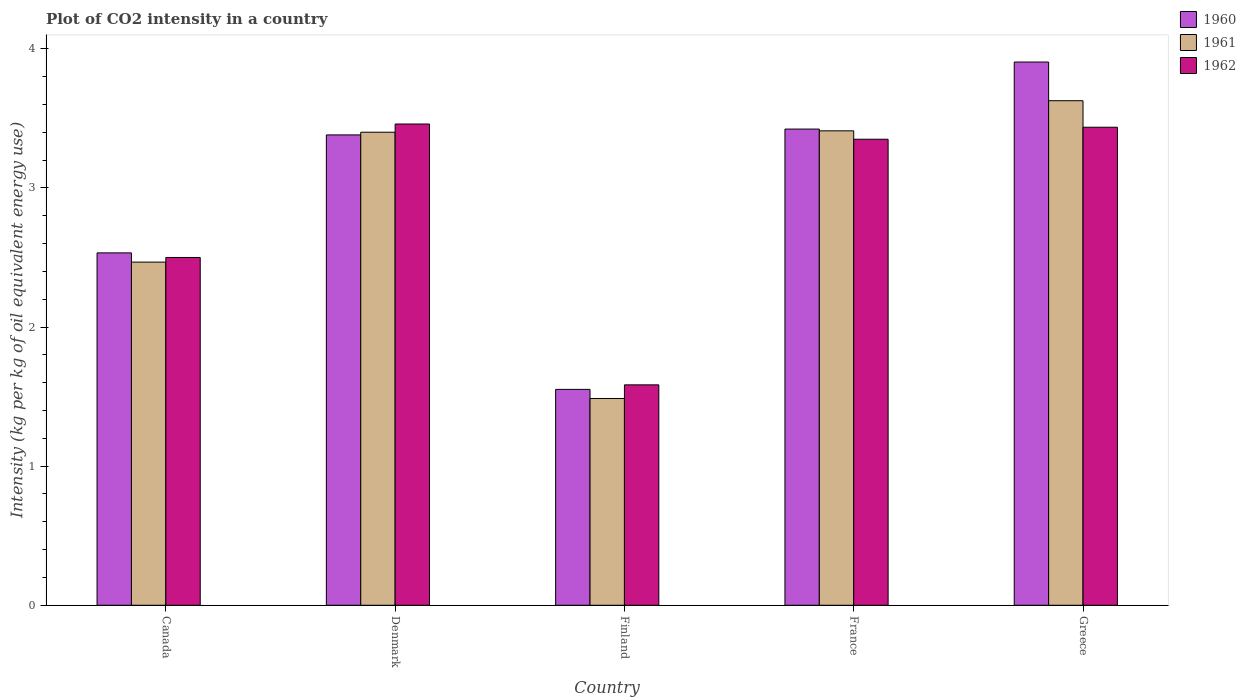Are the number of bars on each tick of the X-axis equal?
Make the answer very short. Yes. How many bars are there on the 5th tick from the left?
Offer a very short reply. 3. How many bars are there on the 5th tick from the right?
Keep it short and to the point. 3. What is the CO2 intensity in in 1961 in Greece?
Give a very brief answer. 3.63. Across all countries, what is the maximum CO2 intensity in in 1962?
Give a very brief answer. 3.46. Across all countries, what is the minimum CO2 intensity in in 1961?
Ensure brevity in your answer.  1.49. In which country was the CO2 intensity in in 1961 maximum?
Your answer should be very brief. Greece. What is the total CO2 intensity in in 1961 in the graph?
Your response must be concise. 14.39. What is the difference between the CO2 intensity in in 1961 in Canada and that in Greece?
Offer a terse response. -1.16. What is the difference between the CO2 intensity in in 1961 in France and the CO2 intensity in in 1962 in Greece?
Provide a short and direct response. -0.03. What is the average CO2 intensity in in 1961 per country?
Offer a terse response. 2.88. What is the difference between the CO2 intensity in of/in 1960 and CO2 intensity in of/in 1962 in France?
Your answer should be compact. 0.07. In how many countries, is the CO2 intensity in in 1960 greater than 3.4 kg?
Give a very brief answer. 2. What is the ratio of the CO2 intensity in in 1962 in Canada to that in Denmark?
Your answer should be very brief. 0.72. Is the difference between the CO2 intensity in in 1960 in Canada and Greece greater than the difference between the CO2 intensity in in 1962 in Canada and Greece?
Provide a succinct answer. No. What is the difference between the highest and the second highest CO2 intensity in in 1961?
Offer a very short reply. -0.22. What is the difference between the highest and the lowest CO2 intensity in in 1962?
Offer a terse response. 1.88. What does the 1st bar from the right in Denmark represents?
Your response must be concise. 1962. Is it the case that in every country, the sum of the CO2 intensity in in 1961 and CO2 intensity in in 1960 is greater than the CO2 intensity in in 1962?
Ensure brevity in your answer.  Yes. How many bars are there?
Your answer should be very brief. 15. Are the values on the major ticks of Y-axis written in scientific E-notation?
Make the answer very short. No. Where does the legend appear in the graph?
Provide a succinct answer. Top right. How many legend labels are there?
Offer a very short reply. 3. How are the legend labels stacked?
Offer a very short reply. Vertical. What is the title of the graph?
Your answer should be compact. Plot of CO2 intensity in a country. Does "1996" appear as one of the legend labels in the graph?
Your response must be concise. No. What is the label or title of the X-axis?
Your response must be concise. Country. What is the label or title of the Y-axis?
Your answer should be very brief. Intensity (kg per kg of oil equivalent energy use). What is the Intensity (kg per kg of oil equivalent energy use) in 1960 in Canada?
Offer a terse response. 2.53. What is the Intensity (kg per kg of oil equivalent energy use) of 1961 in Canada?
Your response must be concise. 2.47. What is the Intensity (kg per kg of oil equivalent energy use) of 1962 in Canada?
Offer a very short reply. 2.5. What is the Intensity (kg per kg of oil equivalent energy use) of 1960 in Denmark?
Your answer should be compact. 3.38. What is the Intensity (kg per kg of oil equivalent energy use) of 1961 in Denmark?
Offer a terse response. 3.4. What is the Intensity (kg per kg of oil equivalent energy use) in 1962 in Denmark?
Your answer should be very brief. 3.46. What is the Intensity (kg per kg of oil equivalent energy use) of 1960 in Finland?
Make the answer very short. 1.55. What is the Intensity (kg per kg of oil equivalent energy use) of 1961 in Finland?
Offer a terse response. 1.49. What is the Intensity (kg per kg of oil equivalent energy use) of 1962 in Finland?
Make the answer very short. 1.58. What is the Intensity (kg per kg of oil equivalent energy use) in 1960 in France?
Give a very brief answer. 3.42. What is the Intensity (kg per kg of oil equivalent energy use) of 1961 in France?
Ensure brevity in your answer.  3.41. What is the Intensity (kg per kg of oil equivalent energy use) of 1962 in France?
Your response must be concise. 3.35. What is the Intensity (kg per kg of oil equivalent energy use) in 1960 in Greece?
Provide a succinct answer. 3.91. What is the Intensity (kg per kg of oil equivalent energy use) in 1961 in Greece?
Provide a succinct answer. 3.63. What is the Intensity (kg per kg of oil equivalent energy use) of 1962 in Greece?
Your response must be concise. 3.44. Across all countries, what is the maximum Intensity (kg per kg of oil equivalent energy use) of 1960?
Make the answer very short. 3.91. Across all countries, what is the maximum Intensity (kg per kg of oil equivalent energy use) of 1961?
Your answer should be compact. 3.63. Across all countries, what is the maximum Intensity (kg per kg of oil equivalent energy use) in 1962?
Keep it short and to the point. 3.46. Across all countries, what is the minimum Intensity (kg per kg of oil equivalent energy use) in 1960?
Your answer should be compact. 1.55. Across all countries, what is the minimum Intensity (kg per kg of oil equivalent energy use) in 1961?
Ensure brevity in your answer.  1.49. Across all countries, what is the minimum Intensity (kg per kg of oil equivalent energy use) in 1962?
Your response must be concise. 1.58. What is the total Intensity (kg per kg of oil equivalent energy use) of 1960 in the graph?
Your answer should be compact. 14.8. What is the total Intensity (kg per kg of oil equivalent energy use) in 1961 in the graph?
Your answer should be compact. 14.39. What is the total Intensity (kg per kg of oil equivalent energy use) in 1962 in the graph?
Your answer should be compact. 14.33. What is the difference between the Intensity (kg per kg of oil equivalent energy use) of 1960 in Canada and that in Denmark?
Your answer should be compact. -0.85. What is the difference between the Intensity (kg per kg of oil equivalent energy use) of 1961 in Canada and that in Denmark?
Your response must be concise. -0.93. What is the difference between the Intensity (kg per kg of oil equivalent energy use) in 1962 in Canada and that in Denmark?
Your answer should be very brief. -0.96. What is the difference between the Intensity (kg per kg of oil equivalent energy use) of 1960 in Canada and that in Finland?
Provide a short and direct response. 0.98. What is the difference between the Intensity (kg per kg of oil equivalent energy use) of 1961 in Canada and that in Finland?
Offer a terse response. 0.98. What is the difference between the Intensity (kg per kg of oil equivalent energy use) in 1962 in Canada and that in Finland?
Your response must be concise. 0.92. What is the difference between the Intensity (kg per kg of oil equivalent energy use) in 1960 in Canada and that in France?
Your answer should be compact. -0.89. What is the difference between the Intensity (kg per kg of oil equivalent energy use) of 1961 in Canada and that in France?
Your answer should be very brief. -0.94. What is the difference between the Intensity (kg per kg of oil equivalent energy use) of 1962 in Canada and that in France?
Offer a very short reply. -0.85. What is the difference between the Intensity (kg per kg of oil equivalent energy use) in 1960 in Canada and that in Greece?
Make the answer very short. -1.37. What is the difference between the Intensity (kg per kg of oil equivalent energy use) in 1961 in Canada and that in Greece?
Offer a terse response. -1.16. What is the difference between the Intensity (kg per kg of oil equivalent energy use) in 1962 in Canada and that in Greece?
Ensure brevity in your answer.  -0.94. What is the difference between the Intensity (kg per kg of oil equivalent energy use) of 1960 in Denmark and that in Finland?
Offer a very short reply. 1.83. What is the difference between the Intensity (kg per kg of oil equivalent energy use) of 1961 in Denmark and that in Finland?
Make the answer very short. 1.91. What is the difference between the Intensity (kg per kg of oil equivalent energy use) in 1962 in Denmark and that in Finland?
Provide a succinct answer. 1.88. What is the difference between the Intensity (kg per kg of oil equivalent energy use) of 1960 in Denmark and that in France?
Ensure brevity in your answer.  -0.04. What is the difference between the Intensity (kg per kg of oil equivalent energy use) in 1961 in Denmark and that in France?
Your answer should be very brief. -0.01. What is the difference between the Intensity (kg per kg of oil equivalent energy use) in 1962 in Denmark and that in France?
Ensure brevity in your answer.  0.11. What is the difference between the Intensity (kg per kg of oil equivalent energy use) of 1960 in Denmark and that in Greece?
Provide a succinct answer. -0.52. What is the difference between the Intensity (kg per kg of oil equivalent energy use) of 1961 in Denmark and that in Greece?
Provide a short and direct response. -0.23. What is the difference between the Intensity (kg per kg of oil equivalent energy use) of 1962 in Denmark and that in Greece?
Give a very brief answer. 0.02. What is the difference between the Intensity (kg per kg of oil equivalent energy use) in 1960 in Finland and that in France?
Your answer should be very brief. -1.87. What is the difference between the Intensity (kg per kg of oil equivalent energy use) of 1961 in Finland and that in France?
Your response must be concise. -1.92. What is the difference between the Intensity (kg per kg of oil equivalent energy use) in 1962 in Finland and that in France?
Provide a short and direct response. -1.77. What is the difference between the Intensity (kg per kg of oil equivalent energy use) of 1960 in Finland and that in Greece?
Ensure brevity in your answer.  -2.35. What is the difference between the Intensity (kg per kg of oil equivalent energy use) of 1961 in Finland and that in Greece?
Your answer should be very brief. -2.14. What is the difference between the Intensity (kg per kg of oil equivalent energy use) of 1962 in Finland and that in Greece?
Provide a succinct answer. -1.85. What is the difference between the Intensity (kg per kg of oil equivalent energy use) of 1960 in France and that in Greece?
Your answer should be compact. -0.48. What is the difference between the Intensity (kg per kg of oil equivalent energy use) of 1961 in France and that in Greece?
Ensure brevity in your answer.  -0.22. What is the difference between the Intensity (kg per kg of oil equivalent energy use) of 1962 in France and that in Greece?
Make the answer very short. -0.09. What is the difference between the Intensity (kg per kg of oil equivalent energy use) of 1960 in Canada and the Intensity (kg per kg of oil equivalent energy use) of 1961 in Denmark?
Provide a succinct answer. -0.87. What is the difference between the Intensity (kg per kg of oil equivalent energy use) of 1960 in Canada and the Intensity (kg per kg of oil equivalent energy use) of 1962 in Denmark?
Provide a short and direct response. -0.93. What is the difference between the Intensity (kg per kg of oil equivalent energy use) of 1961 in Canada and the Intensity (kg per kg of oil equivalent energy use) of 1962 in Denmark?
Keep it short and to the point. -0.99. What is the difference between the Intensity (kg per kg of oil equivalent energy use) of 1960 in Canada and the Intensity (kg per kg of oil equivalent energy use) of 1961 in Finland?
Your answer should be very brief. 1.05. What is the difference between the Intensity (kg per kg of oil equivalent energy use) in 1960 in Canada and the Intensity (kg per kg of oil equivalent energy use) in 1962 in Finland?
Give a very brief answer. 0.95. What is the difference between the Intensity (kg per kg of oil equivalent energy use) in 1961 in Canada and the Intensity (kg per kg of oil equivalent energy use) in 1962 in Finland?
Ensure brevity in your answer.  0.88. What is the difference between the Intensity (kg per kg of oil equivalent energy use) of 1960 in Canada and the Intensity (kg per kg of oil equivalent energy use) of 1961 in France?
Offer a very short reply. -0.88. What is the difference between the Intensity (kg per kg of oil equivalent energy use) in 1960 in Canada and the Intensity (kg per kg of oil equivalent energy use) in 1962 in France?
Provide a succinct answer. -0.82. What is the difference between the Intensity (kg per kg of oil equivalent energy use) in 1961 in Canada and the Intensity (kg per kg of oil equivalent energy use) in 1962 in France?
Your answer should be very brief. -0.88. What is the difference between the Intensity (kg per kg of oil equivalent energy use) in 1960 in Canada and the Intensity (kg per kg of oil equivalent energy use) in 1961 in Greece?
Give a very brief answer. -1.09. What is the difference between the Intensity (kg per kg of oil equivalent energy use) of 1960 in Canada and the Intensity (kg per kg of oil equivalent energy use) of 1962 in Greece?
Make the answer very short. -0.9. What is the difference between the Intensity (kg per kg of oil equivalent energy use) in 1961 in Canada and the Intensity (kg per kg of oil equivalent energy use) in 1962 in Greece?
Offer a very short reply. -0.97. What is the difference between the Intensity (kg per kg of oil equivalent energy use) in 1960 in Denmark and the Intensity (kg per kg of oil equivalent energy use) in 1961 in Finland?
Your answer should be compact. 1.9. What is the difference between the Intensity (kg per kg of oil equivalent energy use) of 1960 in Denmark and the Intensity (kg per kg of oil equivalent energy use) of 1962 in Finland?
Provide a short and direct response. 1.8. What is the difference between the Intensity (kg per kg of oil equivalent energy use) in 1961 in Denmark and the Intensity (kg per kg of oil equivalent energy use) in 1962 in Finland?
Give a very brief answer. 1.82. What is the difference between the Intensity (kg per kg of oil equivalent energy use) in 1960 in Denmark and the Intensity (kg per kg of oil equivalent energy use) in 1961 in France?
Your answer should be very brief. -0.03. What is the difference between the Intensity (kg per kg of oil equivalent energy use) in 1960 in Denmark and the Intensity (kg per kg of oil equivalent energy use) in 1962 in France?
Your response must be concise. 0.03. What is the difference between the Intensity (kg per kg of oil equivalent energy use) of 1961 in Denmark and the Intensity (kg per kg of oil equivalent energy use) of 1962 in France?
Give a very brief answer. 0.05. What is the difference between the Intensity (kg per kg of oil equivalent energy use) of 1960 in Denmark and the Intensity (kg per kg of oil equivalent energy use) of 1961 in Greece?
Your answer should be very brief. -0.25. What is the difference between the Intensity (kg per kg of oil equivalent energy use) in 1960 in Denmark and the Intensity (kg per kg of oil equivalent energy use) in 1962 in Greece?
Keep it short and to the point. -0.06. What is the difference between the Intensity (kg per kg of oil equivalent energy use) of 1961 in Denmark and the Intensity (kg per kg of oil equivalent energy use) of 1962 in Greece?
Give a very brief answer. -0.04. What is the difference between the Intensity (kg per kg of oil equivalent energy use) in 1960 in Finland and the Intensity (kg per kg of oil equivalent energy use) in 1961 in France?
Provide a succinct answer. -1.86. What is the difference between the Intensity (kg per kg of oil equivalent energy use) in 1960 in Finland and the Intensity (kg per kg of oil equivalent energy use) in 1962 in France?
Provide a succinct answer. -1.8. What is the difference between the Intensity (kg per kg of oil equivalent energy use) of 1961 in Finland and the Intensity (kg per kg of oil equivalent energy use) of 1962 in France?
Keep it short and to the point. -1.86. What is the difference between the Intensity (kg per kg of oil equivalent energy use) in 1960 in Finland and the Intensity (kg per kg of oil equivalent energy use) in 1961 in Greece?
Provide a short and direct response. -2.08. What is the difference between the Intensity (kg per kg of oil equivalent energy use) of 1960 in Finland and the Intensity (kg per kg of oil equivalent energy use) of 1962 in Greece?
Your answer should be compact. -1.88. What is the difference between the Intensity (kg per kg of oil equivalent energy use) of 1961 in Finland and the Intensity (kg per kg of oil equivalent energy use) of 1962 in Greece?
Provide a succinct answer. -1.95. What is the difference between the Intensity (kg per kg of oil equivalent energy use) in 1960 in France and the Intensity (kg per kg of oil equivalent energy use) in 1961 in Greece?
Your response must be concise. -0.2. What is the difference between the Intensity (kg per kg of oil equivalent energy use) in 1960 in France and the Intensity (kg per kg of oil equivalent energy use) in 1962 in Greece?
Provide a succinct answer. -0.01. What is the difference between the Intensity (kg per kg of oil equivalent energy use) of 1961 in France and the Intensity (kg per kg of oil equivalent energy use) of 1962 in Greece?
Offer a terse response. -0.03. What is the average Intensity (kg per kg of oil equivalent energy use) in 1960 per country?
Give a very brief answer. 2.96. What is the average Intensity (kg per kg of oil equivalent energy use) in 1961 per country?
Ensure brevity in your answer.  2.88. What is the average Intensity (kg per kg of oil equivalent energy use) in 1962 per country?
Give a very brief answer. 2.87. What is the difference between the Intensity (kg per kg of oil equivalent energy use) in 1960 and Intensity (kg per kg of oil equivalent energy use) in 1961 in Canada?
Your response must be concise. 0.07. What is the difference between the Intensity (kg per kg of oil equivalent energy use) in 1960 and Intensity (kg per kg of oil equivalent energy use) in 1962 in Canada?
Your response must be concise. 0.03. What is the difference between the Intensity (kg per kg of oil equivalent energy use) in 1961 and Intensity (kg per kg of oil equivalent energy use) in 1962 in Canada?
Ensure brevity in your answer.  -0.03. What is the difference between the Intensity (kg per kg of oil equivalent energy use) of 1960 and Intensity (kg per kg of oil equivalent energy use) of 1961 in Denmark?
Your answer should be compact. -0.02. What is the difference between the Intensity (kg per kg of oil equivalent energy use) in 1960 and Intensity (kg per kg of oil equivalent energy use) in 1962 in Denmark?
Your answer should be compact. -0.08. What is the difference between the Intensity (kg per kg of oil equivalent energy use) in 1961 and Intensity (kg per kg of oil equivalent energy use) in 1962 in Denmark?
Offer a terse response. -0.06. What is the difference between the Intensity (kg per kg of oil equivalent energy use) of 1960 and Intensity (kg per kg of oil equivalent energy use) of 1961 in Finland?
Provide a short and direct response. 0.07. What is the difference between the Intensity (kg per kg of oil equivalent energy use) of 1960 and Intensity (kg per kg of oil equivalent energy use) of 1962 in Finland?
Make the answer very short. -0.03. What is the difference between the Intensity (kg per kg of oil equivalent energy use) of 1961 and Intensity (kg per kg of oil equivalent energy use) of 1962 in Finland?
Give a very brief answer. -0.1. What is the difference between the Intensity (kg per kg of oil equivalent energy use) of 1960 and Intensity (kg per kg of oil equivalent energy use) of 1961 in France?
Keep it short and to the point. 0.01. What is the difference between the Intensity (kg per kg of oil equivalent energy use) in 1960 and Intensity (kg per kg of oil equivalent energy use) in 1962 in France?
Give a very brief answer. 0.07. What is the difference between the Intensity (kg per kg of oil equivalent energy use) of 1961 and Intensity (kg per kg of oil equivalent energy use) of 1962 in France?
Give a very brief answer. 0.06. What is the difference between the Intensity (kg per kg of oil equivalent energy use) in 1960 and Intensity (kg per kg of oil equivalent energy use) in 1961 in Greece?
Give a very brief answer. 0.28. What is the difference between the Intensity (kg per kg of oil equivalent energy use) of 1960 and Intensity (kg per kg of oil equivalent energy use) of 1962 in Greece?
Provide a short and direct response. 0.47. What is the difference between the Intensity (kg per kg of oil equivalent energy use) in 1961 and Intensity (kg per kg of oil equivalent energy use) in 1962 in Greece?
Your answer should be compact. 0.19. What is the ratio of the Intensity (kg per kg of oil equivalent energy use) of 1960 in Canada to that in Denmark?
Make the answer very short. 0.75. What is the ratio of the Intensity (kg per kg of oil equivalent energy use) of 1961 in Canada to that in Denmark?
Offer a very short reply. 0.73. What is the ratio of the Intensity (kg per kg of oil equivalent energy use) in 1962 in Canada to that in Denmark?
Ensure brevity in your answer.  0.72. What is the ratio of the Intensity (kg per kg of oil equivalent energy use) in 1960 in Canada to that in Finland?
Your response must be concise. 1.63. What is the ratio of the Intensity (kg per kg of oil equivalent energy use) in 1961 in Canada to that in Finland?
Your response must be concise. 1.66. What is the ratio of the Intensity (kg per kg of oil equivalent energy use) in 1962 in Canada to that in Finland?
Your answer should be compact. 1.58. What is the ratio of the Intensity (kg per kg of oil equivalent energy use) in 1960 in Canada to that in France?
Offer a terse response. 0.74. What is the ratio of the Intensity (kg per kg of oil equivalent energy use) in 1961 in Canada to that in France?
Your response must be concise. 0.72. What is the ratio of the Intensity (kg per kg of oil equivalent energy use) of 1962 in Canada to that in France?
Offer a terse response. 0.75. What is the ratio of the Intensity (kg per kg of oil equivalent energy use) of 1960 in Canada to that in Greece?
Ensure brevity in your answer.  0.65. What is the ratio of the Intensity (kg per kg of oil equivalent energy use) in 1961 in Canada to that in Greece?
Keep it short and to the point. 0.68. What is the ratio of the Intensity (kg per kg of oil equivalent energy use) in 1962 in Canada to that in Greece?
Your answer should be very brief. 0.73. What is the ratio of the Intensity (kg per kg of oil equivalent energy use) in 1960 in Denmark to that in Finland?
Ensure brevity in your answer.  2.18. What is the ratio of the Intensity (kg per kg of oil equivalent energy use) in 1961 in Denmark to that in Finland?
Make the answer very short. 2.29. What is the ratio of the Intensity (kg per kg of oil equivalent energy use) of 1962 in Denmark to that in Finland?
Your answer should be compact. 2.18. What is the ratio of the Intensity (kg per kg of oil equivalent energy use) of 1961 in Denmark to that in France?
Provide a succinct answer. 1. What is the ratio of the Intensity (kg per kg of oil equivalent energy use) in 1962 in Denmark to that in France?
Offer a very short reply. 1.03. What is the ratio of the Intensity (kg per kg of oil equivalent energy use) of 1960 in Denmark to that in Greece?
Your answer should be very brief. 0.87. What is the ratio of the Intensity (kg per kg of oil equivalent energy use) of 1961 in Denmark to that in Greece?
Give a very brief answer. 0.94. What is the ratio of the Intensity (kg per kg of oil equivalent energy use) in 1962 in Denmark to that in Greece?
Make the answer very short. 1.01. What is the ratio of the Intensity (kg per kg of oil equivalent energy use) of 1960 in Finland to that in France?
Make the answer very short. 0.45. What is the ratio of the Intensity (kg per kg of oil equivalent energy use) in 1961 in Finland to that in France?
Make the answer very short. 0.44. What is the ratio of the Intensity (kg per kg of oil equivalent energy use) of 1962 in Finland to that in France?
Your answer should be very brief. 0.47. What is the ratio of the Intensity (kg per kg of oil equivalent energy use) in 1960 in Finland to that in Greece?
Offer a terse response. 0.4. What is the ratio of the Intensity (kg per kg of oil equivalent energy use) in 1961 in Finland to that in Greece?
Your response must be concise. 0.41. What is the ratio of the Intensity (kg per kg of oil equivalent energy use) of 1962 in Finland to that in Greece?
Make the answer very short. 0.46. What is the ratio of the Intensity (kg per kg of oil equivalent energy use) of 1960 in France to that in Greece?
Ensure brevity in your answer.  0.88. What is the ratio of the Intensity (kg per kg of oil equivalent energy use) in 1961 in France to that in Greece?
Your answer should be compact. 0.94. What is the ratio of the Intensity (kg per kg of oil equivalent energy use) of 1962 in France to that in Greece?
Offer a terse response. 0.97. What is the difference between the highest and the second highest Intensity (kg per kg of oil equivalent energy use) of 1960?
Ensure brevity in your answer.  0.48. What is the difference between the highest and the second highest Intensity (kg per kg of oil equivalent energy use) in 1961?
Your response must be concise. 0.22. What is the difference between the highest and the second highest Intensity (kg per kg of oil equivalent energy use) of 1962?
Provide a short and direct response. 0.02. What is the difference between the highest and the lowest Intensity (kg per kg of oil equivalent energy use) in 1960?
Offer a very short reply. 2.35. What is the difference between the highest and the lowest Intensity (kg per kg of oil equivalent energy use) in 1961?
Make the answer very short. 2.14. What is the difference between the highest and the lowest Intensity (kg per kg of oil equivalent energy use) of 1962?
Give a very brief answer. 1.88. 